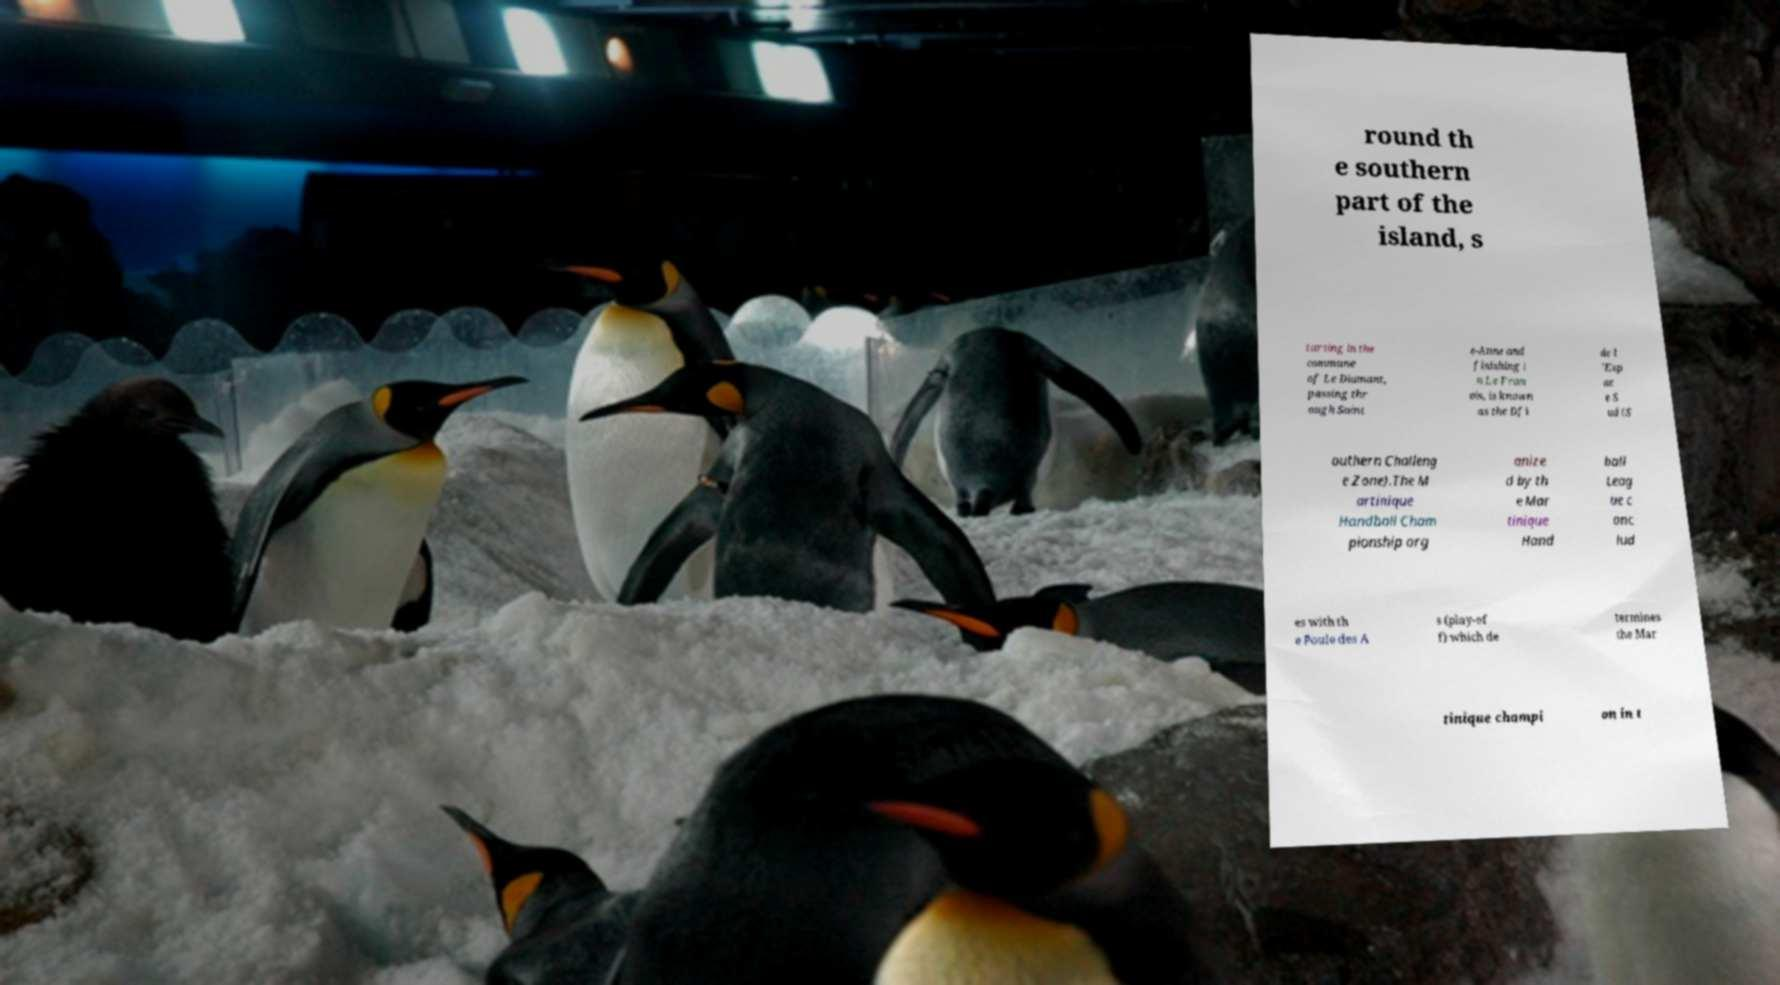There's text embedded in this image that I need extracted. Can you transcribe it verbatim? round th e southern part of the island, s tarting in the commune of Le Diamant, passing thr ough Saint e-Anne and finishing i n Le Fran ois, is known as the Dfi de l 'Esp ac e S ud (S outhern Challeng e Zone).The M artinique Handball Cham pionship org anize d by th e Mar tinique Hand ball Leag ue c onc lud es with th e Poule des A s (play-of f) which de termines the Mar tinique champi on in t 